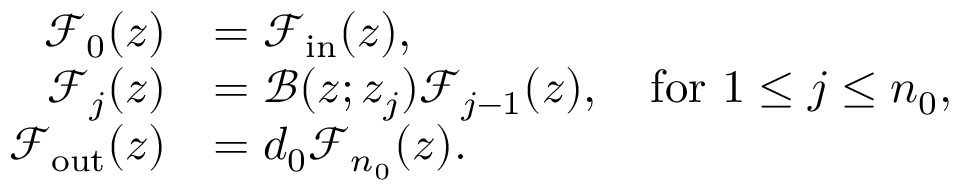Convert formula to latex. <formula><loc_0><loc_0><loc_500><loc_500>\begin{array} { r l } { \mathcal { F } _ { 0 } ( z ) } & { = \mathcal { F } _ { i n } ( z ) , } \\ { \mathcal { F } _ { j } ( z ) } & { = \mathcal { B } ( z ; z _ { j } ) \mathcal { F } _ { j - 1 } ( z ) , \quad f o r \ 1 \leq j \leq n _ { 0 } , } \\ { \mathcal { F } _ { o u t } ( z ) } & { = d _ { 0 } \mathcal { F } _ { n _ { 0 } } ( z ) . } \end{array}</formula> 